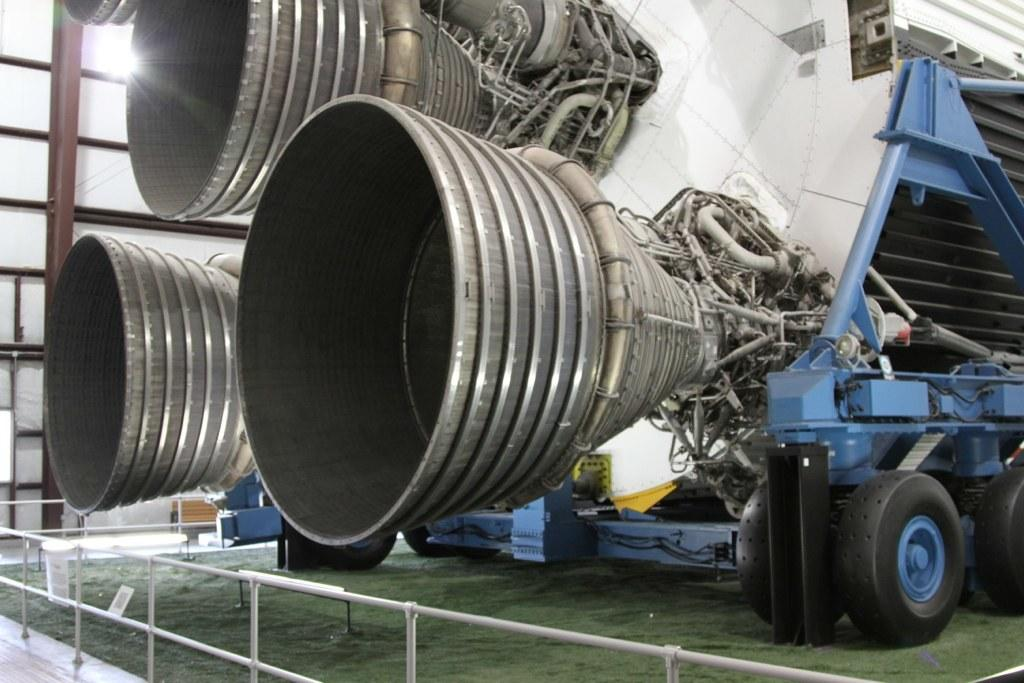What is the machine attached to in the image? The machine is attached to a vehicle in the image. What type of natural environment can be seen in the image? There is grass visible in the image. What type of barrier is present in the image? There is a fence in the image. What book is the person reading in the image? There is no person reading a book in the image. What type of rock can be seen in the image? There is no rock present in the image. 